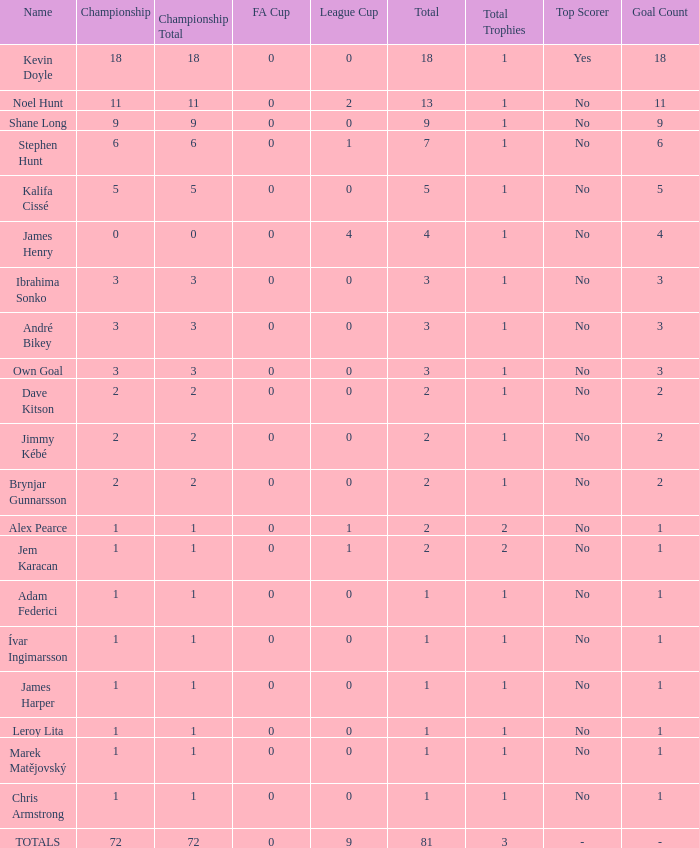What is the championship of Jem Karacan that has a total of 2 and a league cup more than 0? 1.0. 